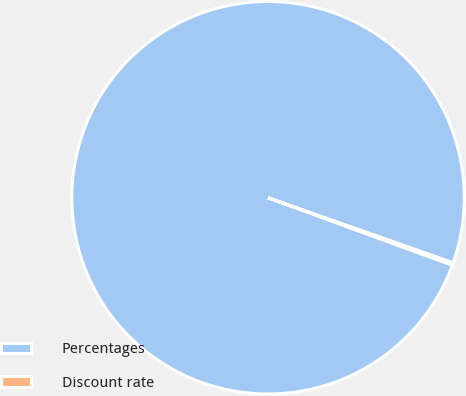Convert chart to OTSL. <chart><loc_0><loc_0><loc_500><loc_500><pie_chart><fcel>Percentages<fcel>Discount rate<nl><fcel>99.8%<fcel>0.2%<nl></chart> 